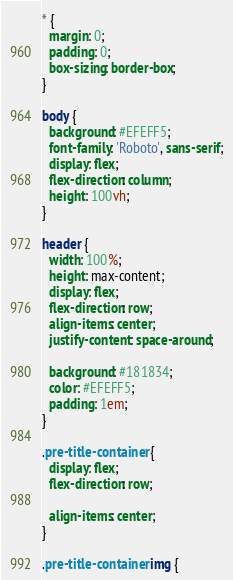Convert code to text. <code><loc_0><loc_0><loc_500><loc_500><_CSS_>* {
  margin: 0;
  padding: 0;
  box-sizing: border-box;
}

body {
  background: #EFEFF5;
  font-family: 'Roboto', sans-serif;
  display: flex;
  flex-direction: column;
  height: 100vh;
}

header {
  width: 100%;
  height: max-content;
  display: flex;
  flex-direction: row;
  align-items: center;
  justify-content: space-around;

  background: #181834;
  color: #EFEFF5;
  padding: 1em;
}

.pre-title-container {
  display: flex;
  flex-direction: row;
  
  align-items: center;
}

.pre-title-container img {</code> 